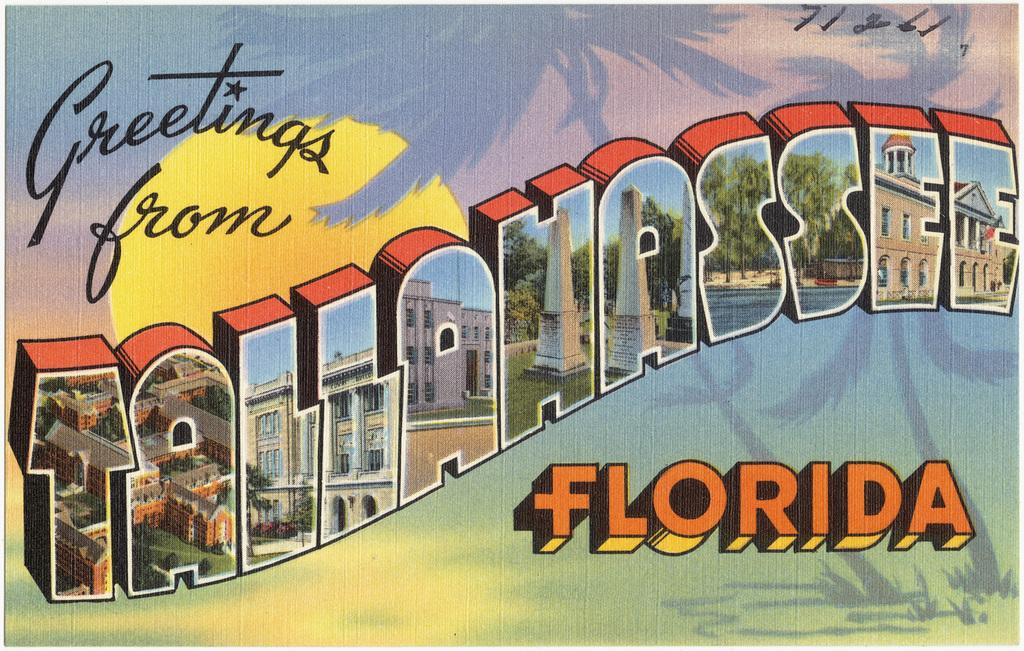<image>
Relay a brief, clear account of the picture shown. A postcard that reads Greetings from Tallahassee Florida. 